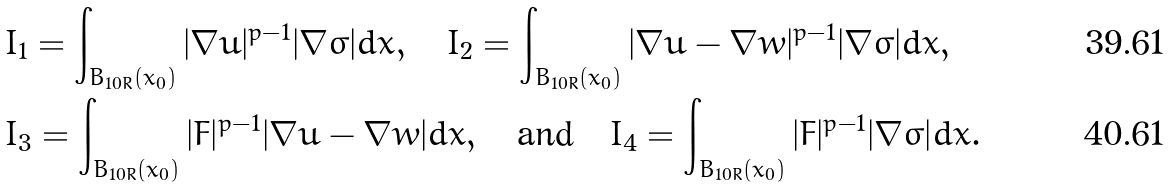Convert formula to latex. <formula><loc_0><loc_0><loc_500><loc_500>& I _ { 1 } = \int _ { B _ { 1 0 R } ( x _ { 0 } ) } | \nabla u | ^ { p - 1 } | \nabla \sigma | d x , \quad I _ { 2 } = \int _ { B _ { 1 0 R } ( x _ { 0 } ) } | \nabla u - \nabla w | ^ { p - 1 } | \nabla \sigma | d x , \\ & I _ { 3 } = \int _ { B _ { 1 0 R } ( x _ { 0 } ) } | F | ^ { p - 1 } | \nabla u - \nabla w | d x , \quad \text {and} \quad I _ { 4 } = \int _ { B _ { 1 0 R } ( x _ { 0 } ) } | F | ^ { p - 1 } | \nabla \sigma | d x .</formula> 